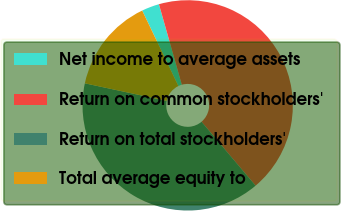<chart> <loc_0><loc_0><loc_500><loc_500><pie_chart><fcel>Net income to average assets<fcel>Return on common stockholders'<fcel>Return on total stockholders'<fcel>Total average equity to<nl><fcel>2.71%<fcel>43.23%<fcel>39.53%<fcel>14.52%<nl></chart> 